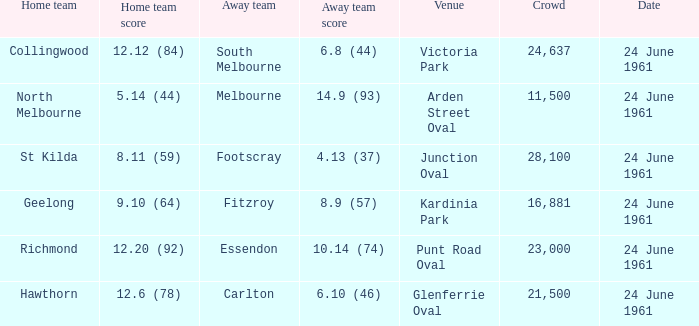Who was the home team that scored 12.6 (78)? Hawthorn. 